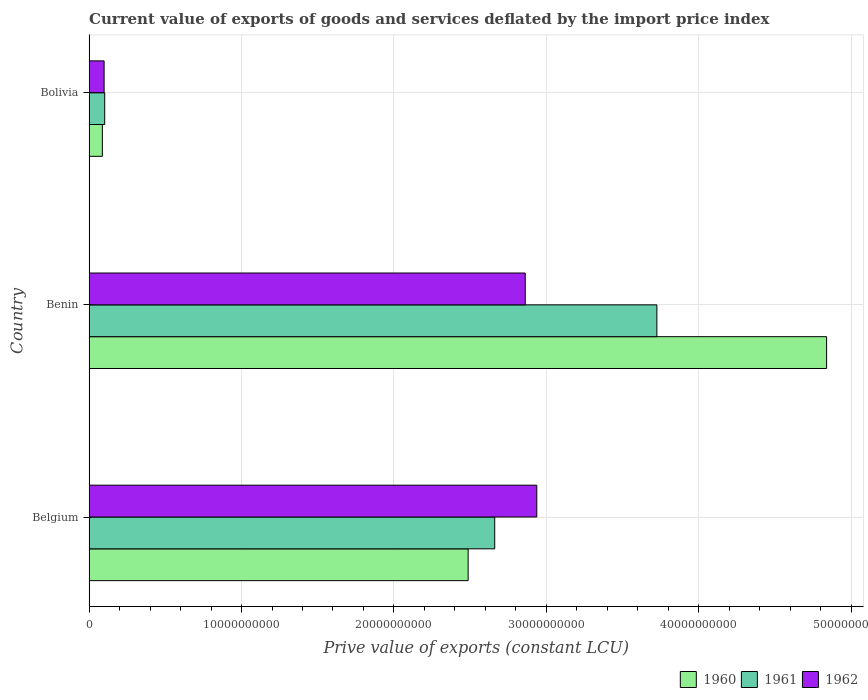How many groups of bars are there?
Keep it short and to the point. 3. How many bars are there on the 3rd tick from the bottom?
Ensure brevity in your answer.  3. What is the label of the 1st group of bars from the top?
Make the answer very short. Bolivia. In how many cases, is the number of bars for a given country not equal to the number of legend labels?
Your answer should be compact. 0. What is the prive value of exports in 1962 in Belgium?
Your answer should be very brief. 2.94e+1. Across all countries, what is the maximum prive value of exports in 1960?
Offer a very short reply. 4.84e+1. Across all countries, what is the minimum prive value of exports in 1960?
Provide a short and direct response. 8.70e+08. In which country was the prive value of exports in 1961 maximum?
Your answer should be very brief. Benin. What is the total prive value of exports in 1960 in the graph?
Your answer should be compact. 7.41e+1. What is the difference between the prive value of exports in 1961 in Belgium and that in Bolivia?
Offer a very short reply. 2.56e+1. What is the difference between the prive value of exports in 1961 in Bolivia and the prive value of exports in 1960 in Benin?
Offer a terse response. -4.74e+1. What is the average prive value of exports in 1960 per country?
Your answer should be compact. 2.47e+1. What is the difference between the prive value of exports in 1960 and prive value of exports in 1962 in Belgium?
Your response must be concise. -4.50e+09. In how many countries, is the prive value of exports in 1961 greater than 30000000000 LCU?
Ensure brevity in your answer.  1. What is the ratio of the prive value of exports in 1960 in Belgium to that in Bolivia?
Offer a terse response. 28.57. Is the prive value of exports in 1960 in Belgium less than that in Bolivia?
Make the answer very short. No. Is the difference between the prive value of exports in 1960 in Belgium and Benin greater than the difference between the prive value of exports in 1962 in Belgium and Benin?
Provide a succinct answer. No. What is the difference between the highest and the second highest prive value of exports in 1960?
Offer a terse response. 2.35e+1. What is the difference between the highest and the lowest prive value of exports in 1962?
Offer a terse response. 2.84e+1. Is it the case that in every country, the sum of the prive value of exports in 1960 and prive value of exports in 1961 is greater than the prive value of exports in 1962?
Your answer should be compact. Yes. What is the difference between two consecutive major ticks on the X-axis?
Your response must be concise. 1.00e+1. Are the values on the major ticks of X-axis written in scientific E-notation?
Your response must be concise. No. Does the graph contain grids?
Give a very brief answer. Yes. Where does the legend appear in the graph?
Your answer should be compact. Bottom right. How are the legend labels stacked?
Make the answer very short. Horizontal. What is the title of the graph?
Keep it short and to the point. Current value of exports of goods and services deflated by the import price index. What is the label or title of the X-axis?
Provide a succinct answer. Prive value of exports (constant LCU). What is the label or title of the Y-axis?
Your answer should be compact. Country. What is the Prive value of exports (constant LCU) in 1960 in Belgium?
Offer a terse response. 2.49e+1. What is the Prive value of exports (constant LCU) of 1961 in Belgium?
Offer a very short reply. 2.66e+1. What is the Prive value of exports (constant LCU) of 1962 in Belgium?
Ensure brevity in your answer.  2.94e+1. What is the Prive value of exports (constant LCU) of 1960 in Benin?
Give a very brief answer. 4.84e+1. What is the Prive value of exports (constant LCU) in 1961 in Benin?
Your response must be concise. 3.73e+1. What is the Prive value of exports (constant LCU) of 1962 in Benin?
Offer a very short reply. 2.86e+1. What is the Prive value of exports (constant LCU) of 1960 in Bolivia?
Offer a very short reply. 8.70e+08. What is the Prive value of exports (constant LCU) in 1961 in Bolivia?
Ensure brevity in your answer.  1.02e+09. What is the Prive value of exports (constant LCU) in 1962 in Bolivia?
Give a very brief answer. 9.85e+08. Across all countries, what is the maximum Prive value of exports (constant LCU) of 1960?
Give a very brief answer. 4.84e+1. Across all countries, what is the maximum Prive value of exports (constant LCU) of 1961?
Make the answer very short. 3.73e+1. Across all countries, what is the maximum Prive value of exports (constant LCU) of 1962?
Give a very brief answer. 2.94e+1. Across all countries, what is the minimum Prive value of exports (constant LCU) of 1960?
Provide a succinct answer. 8.70e+08. Across all countries, what is the minimum Prive value of exports (constant LCU) in 1961?
Keep it short and to the point. 1.02e+09. Across all countries, what is the minimum Prive value of exports (constant LCU) of 1962?
Your answer should be very brief. 9.85e+08. What is the total Prive value of exports (constant LCU) of 1960 in the graph?
Make the answer very short. 7.41e+1. What is the total Prive value of exports (constant LCU) in 1961 in the graph?
Provide a short and direct response. 6.49e+1. What is the total Prive value of exports (constant LCU) of 1962 in the graph?
Give a very brief answer. 5.90e+1. What is the difference between the Prive value of exports (constant LCU) of 1960 in Belgium and that in Benin?
Offer a terse response. -2.35e+1. What is the difference between the Prive value of exports (constant LCU) of 1961 in Belgium and that in Benin?
Your answer should be compact. -1.06e+1. What is the difference between the Prive value of exports (constant LCU) in 1962 in Belgium and that in Benin?
Offer a very short reply. 7.58e+08. What is the difference between the Prive value of exports (constant LCU) in 1960 in Belgium and that in Bolivia?
Ensure brevity in your answer.  2.40e+1. What is the difference between the Prive value of exports (constant LCU) of 1961 in Belgium and that in Bolivia?
Offer a terse response. 2.56e+1. What is the difference between the Prive value of exports (constant LCU) in 1962 in Belgium and that in Bolivia?
Ensure brevity in your answer.  2.84e+1. What is the difference between the Prive value of exports (constant LCU) of 1960 in Benin and that in Bolivia?
Offer a terse response. 4.75e+1. What is the difference between the Prive value of exports (constant LCU) in 1961 in Benin and that in Bolivia?
Give a very brief answer. 3.62e+1. What is the difference between the Prive value of exports (constant LCU) in 1962 in Benin and that in Bolivia?
Offer a terse response. 2.76e+1. What is the difference between the Prive value of exports (constant LCU) in 1960 in Belgium and the Prive value of exports (constant LCU) in 1961 in Benin?
Your response must be concise. -1.24e+1. What is the difference between the Prive value of exports (constant LCU) of 1960 in Belgium and the Prive value of exports (constant LCU) of 1962 in Benin?
Offer a very short reply. -3.75e+09. What is the difference between the Prive value of exports (constant LCU) of 1961 in Belgium and the Prive value of exports (constant LCU) of 1962 in Benin?
Keep it short and to the point. -2.00e+09. What is the difference between the Prive value of exports (constant LCU) of 1960 in Belgium and the Prive value of exports (constant LCU) of 1961 in Bolivia?
Give a very brief answer. 2.38e+1. What is the difference between the Prive value of exports (constant LCU) in 1960 in Belgium and the Prive value of exports (constant LCU) in 1962 in Bolivia?
Provide a succinct answer. 2.39e+1. What is the difference between the Prive value of exports (constant LCU) of 1961 in Belgium and the Prive value of exports (constant LCU) of 1962 in Bolivia?
Make the answer very short. 2.56e+1. What is the difference between the Prive value of exports (constant LCU) in 1960 in Benin and the Prive value of exports (constant LCU) in 1961 in Bolivia?
Ensure brevity in your answer.  4.74e+1. What is the difference between the Prive value of exports (constant LCU) of 1960 in Benin and the Prive value of exports (constant LCU) of 1962 in Bolivia?
Your answer should be very brief. 4.74e+1. What is the difference between the Prive value of exports (constant LCU) of 1961 in Benin and the Prive value of exports (constant LCU) of 1962 in Bolivia?
Make the answer very short. 3.63e+1. What is the average Prive value of exports (constant LCU) in 1960 per country?
Give a very brief answer. 2.47e+1. What is the average Prive value of exports (constant LCU) in 1961 per country?
Your answer should be compact. 2.16e+1. What is the average Prive value of exports (constant LCU) in 1962 per country?
Your response must be concise. 1.97e+1. What is the difference between the Prive value of exports (constant LCU) in 1960 and Prive value of exports (constant LCU) in 1961 in Belgium?
Offer a very short reply. -1.74e+09. What is the difference between the Prive value of exports (constant LCU) in 1960 and Prive value of exports (constant LCU) in 1962 in Belgium?
Make the answer very short. -4.50e+09. What is the difference between the Prive value of exports (constant LCU) of 1961 and Prive value of exports (constant LCU) of 1962 in Belgium?
Offer a terse response. -2.76e+09. What is the difference between the Prive value of exports (constant LCU) of 1960 and Prive value of exports (constant LCU) of 1961 in Benin?
Your answer should be compact. 1.11e+1. What is the difference between the Prive value of exports (constant LCU) in 1960 and Prive value of exports (constant LCU) in 1962 in Benin?
Your response must be concise. 1.98e+1. What is the difference between the Prive value of exports (constant LCU) in 1961 and Prive value of exports (constant LCU) in 1962 in Benin?
Your response must be concise. 8.64e+09. What is the difference between the Prive value of exports (constant LCU) of 1960 and Prive value of exports (constant LCU) of 1961 in Bolivia?
Your answer should be very brief. -1.53e+08. What is the difference between the Prive value of exports (constant LCU) in 1960 and Prive value of exports (constant LCU) in 1962 in Bolivia?
Ensure brevity in your answer.  -1.15e+08. What is the difference between the Prive value of exports (constant LCU) of 1961 and Prive value of exports (constant LCU) of 1962 in Bolivia?
Offer a terse response. 3.86e+07. What is the ratio of the Prive value of exports (constant LCU) of 1960 in Belgium to that in Benin?
Ensure brevity in your answer.  0.51. What is the ratio of the Prive value of exports (constant LCU) of 1961 in Belgium to that in Benin?
Your response must be concise. 0.71. What is the ratio of the Prive value of exports (constant LCU) in 1962 in Belgium to that in Benin?
Offer a very short reply. 1.03. What is the ratio of the Prive value of exports (constant LCU) in 1960 in Belgium to that in Bolivia?
Your answer should be compact. 28.57. What is the ratio of the Prive value of exports (constant LCU) in 1961 in Belgium to that in Bolivia?
Keep it short and to the point. 26. What is the ratio of the Prive value of exports (constant LCU) of 1962 in Belgium to that in Bolivia?
Ensure brevity in your answer.  29.82. What is the ratio of the Prive value of exports (constant LCU) in 1960 in Benin to that in Bolivia?
Keep it short and to the point. 55.59. What is the ratio of the Prive value of exports (constant LCU) in 1961 in Benin to that in Bolivia?
Your answer should be very brief. 36.39. What is the ratio of the Prive value of exports (constant LCU) in 1962 in Benin to that in Bolivia?
Offer a very short reply. 29.05. What is the difference between the highest and the second highest Prive value of exports (constant LCU) in 1960?
Provide a short and direct response. 2.35e+1. What is the difference between the highest and the second highest Prive value of exports (constant LCU) in 1961?
Make the answer very short. 1.06e+1. What is the difference between the highest and the second highest Prive value of exports (constant LCU) of 1962?
Ensure brevity in your answer.  7.58e+08. What is the difference between the highest and the lowest Prive value of exports (constant LCU) of 1960?
Your answer should be very brief. 4.75e+1. What is the difference between the highest and the lowest Prive value of exports (constant LCU) in 1961?
Give a very brief answer. 3.62e+1. What is the difference between the highest and the lowest Prive value of exports (constant LCU) of 1962?
Offer a very short reply. 2.84e+1. 